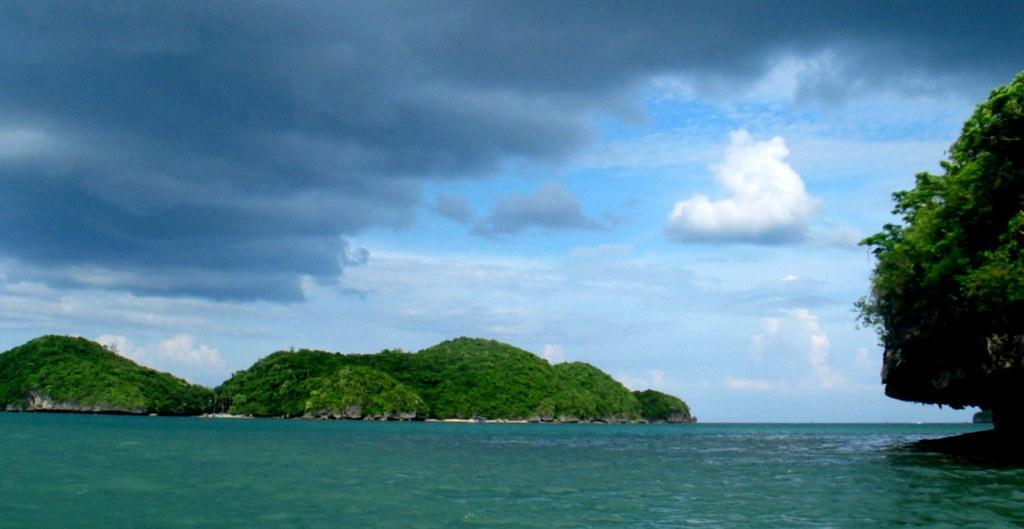Please provide a concise description of this image. In this image, we can see some water. There are a few hills and trees. We can see the sky with clouds. 